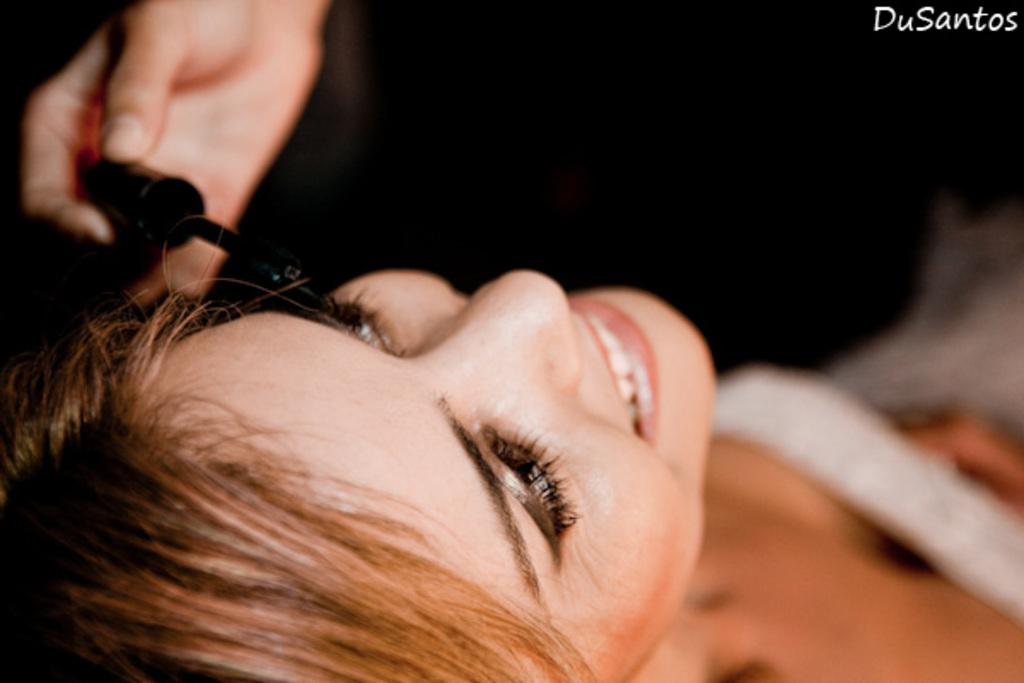Who is the main subject in the image? There is a woman in the center of the image. What is the woman's facial expression? The woman is smiling. Whose hand is visible in the image? There is another person's hand visible in the image. What is the woman holding in the image? The woman is holding an object. What is the woman feeling ashamed about in the image? There is no indication in the image that the woman is feeling ashamed, as she is smiling. Can you describe the space station visible in the image? There is no space station present in the image; it features a woman and another person's hand. 